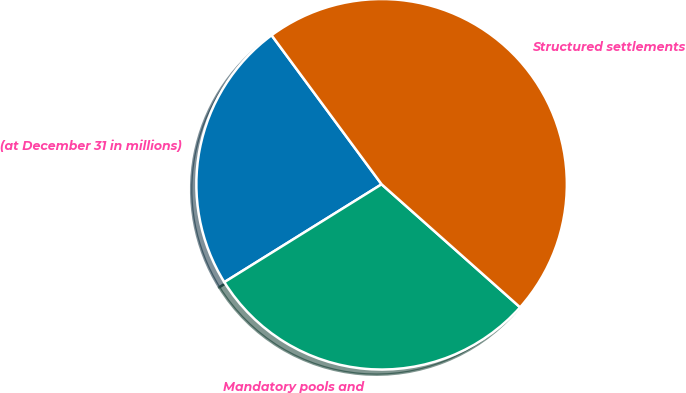<chart> <loc_0><loc_0><loc_500><loc_500><pie_chart><fcel>(at December 31 in millions)<fcel>Mandatory pools and<fcel>Structured settlements<nl><fcel>23.74%<fcel>29.58%<fcel>46.68%<nl></chart> 